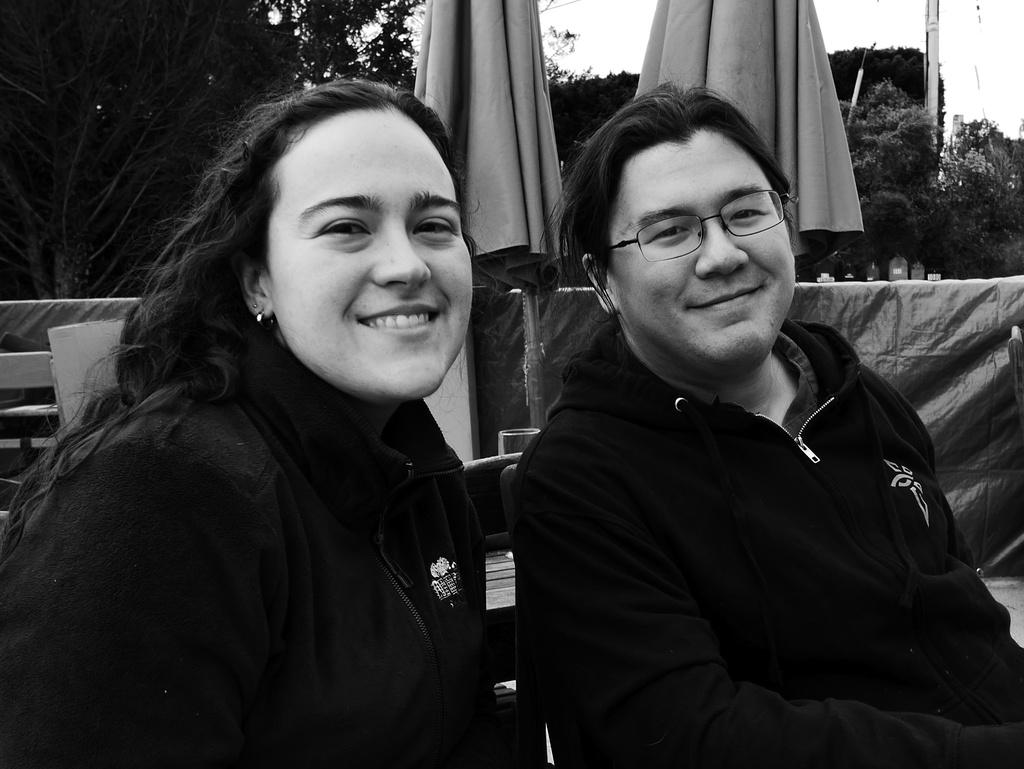How many people are present in the image? There are two persons in the image. What can be seen in the background of the image? There are trees in the background of the image. What part of the natural environment is visible in the image? The sky is visible in the image. What type of chain can be seen connecting the two persons in the image? There is no chain present in the image connecting the two persons. How many people are in the crowd in the image? There is no crowd present in the image; it features two persons. 